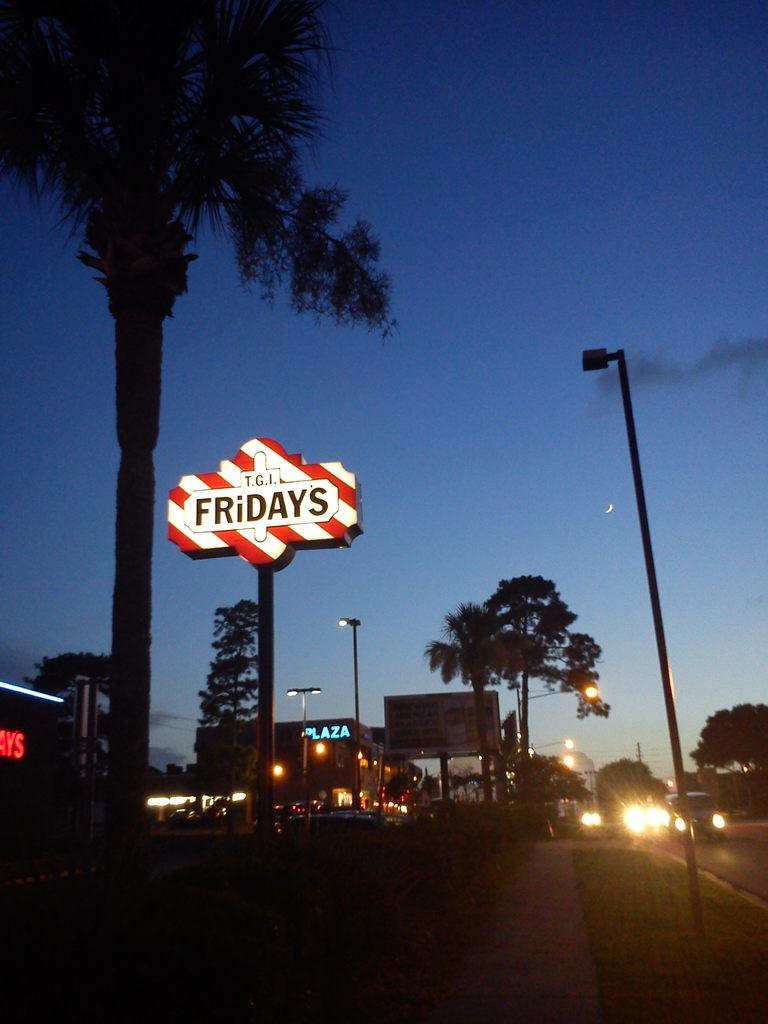What is the main object in the image? There is a name board in the image. What can be seen attached to poles in the image? Signal lights are attached to poles in the image. What type of structures are visible in the background of the image? There are buildings in the background of the image. What is moving in the background of the image? Vehicles are present on the road in the background of the image. What is visible above the buildings and vehicles in the image? The sky is visible in the background of the image. How long does it take for the minute hand to fall in the image? There is no clock or minute hand present in the image, so it is not possible to answer that question. 